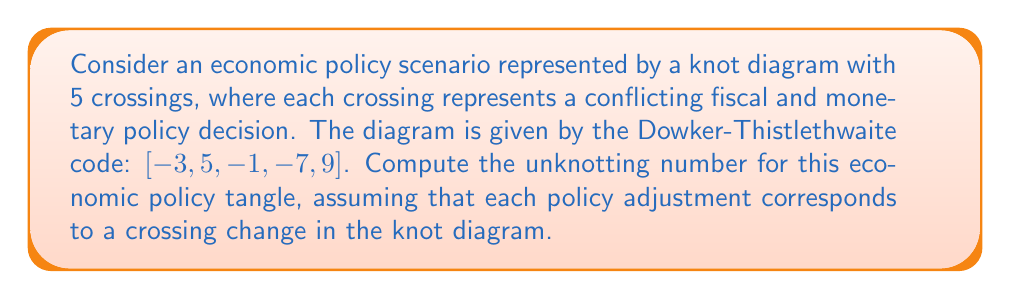What is the answer to this math problem? To solve this problem, we'll follow these steps:

1) First, we need to understand what the given Dowker-Thistlethwaite code represents. The code [-3, 5, -1, -7, 9] describes a knot with 5 crossings.

2) In knot theory, the unknotting number is the minimum number of crossing changes needed to transform a knot into the unknot (the trivial knot).

3) For a knot with 5 crossings, the maximum possible unknotting number is 2. This is because any knot with 5 or fewer crossings can be unknotted with at most 2 crossing changes.

4) To determine the exact unknotting number, we need to analyze the knot structure:

   a) The given code represents a knot known as 5_2 in the Rolfsen table of knots.
   
   b) The 5_2 knot is known to have an unknotting number of 2.

5) In the context of our economic policy scenario:
   
   - Each crossing represents a conflicting fiscal and monetary policy decision.
   - The unknotting number represents the minimum number of policy adjustments needed to resolve all conflicts and achieve a coherent economic strategy.

6) Therefore, at least 2 policy adjustments (corresponding to 2 crossing changes in the knot diagram) are necessary to resolve all conflicts in this economic policy scenario.

This result suggests that the economic policy tangle represented by this knot is relatively complex, requiring multiple adjustments to achieve coherence.
Answer: 2 